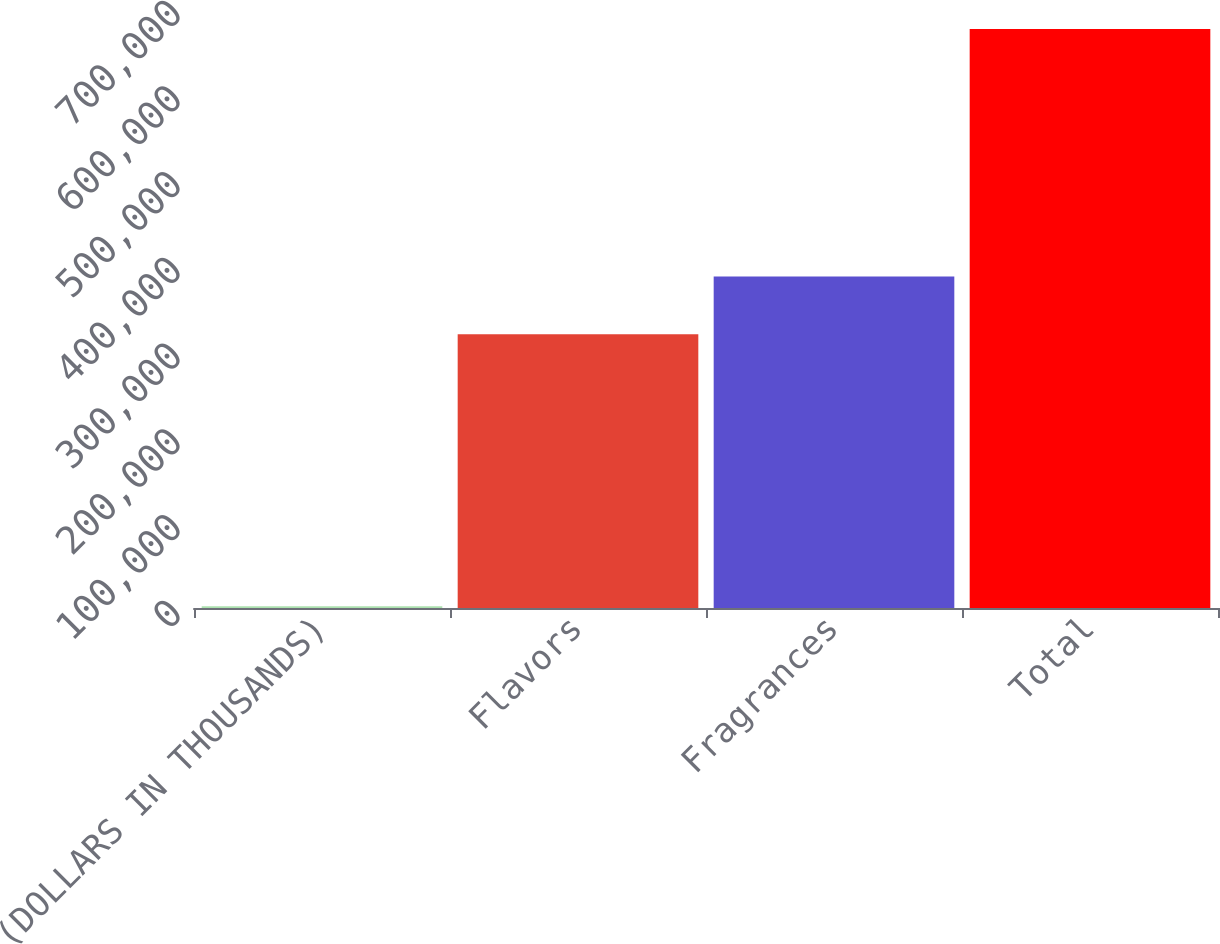Convert chart to OTSL. <chart><loc_0><loc_0><loc_500><loc_500><bar_chart><fcel>(DOLLARS IN THOUSANDS)<fcel>Flavors<fcel>Fragrances<fcel>Total<nl><fcel>2014<fcel>319479<fcel>386826<fcel>675484<nl></chart> 